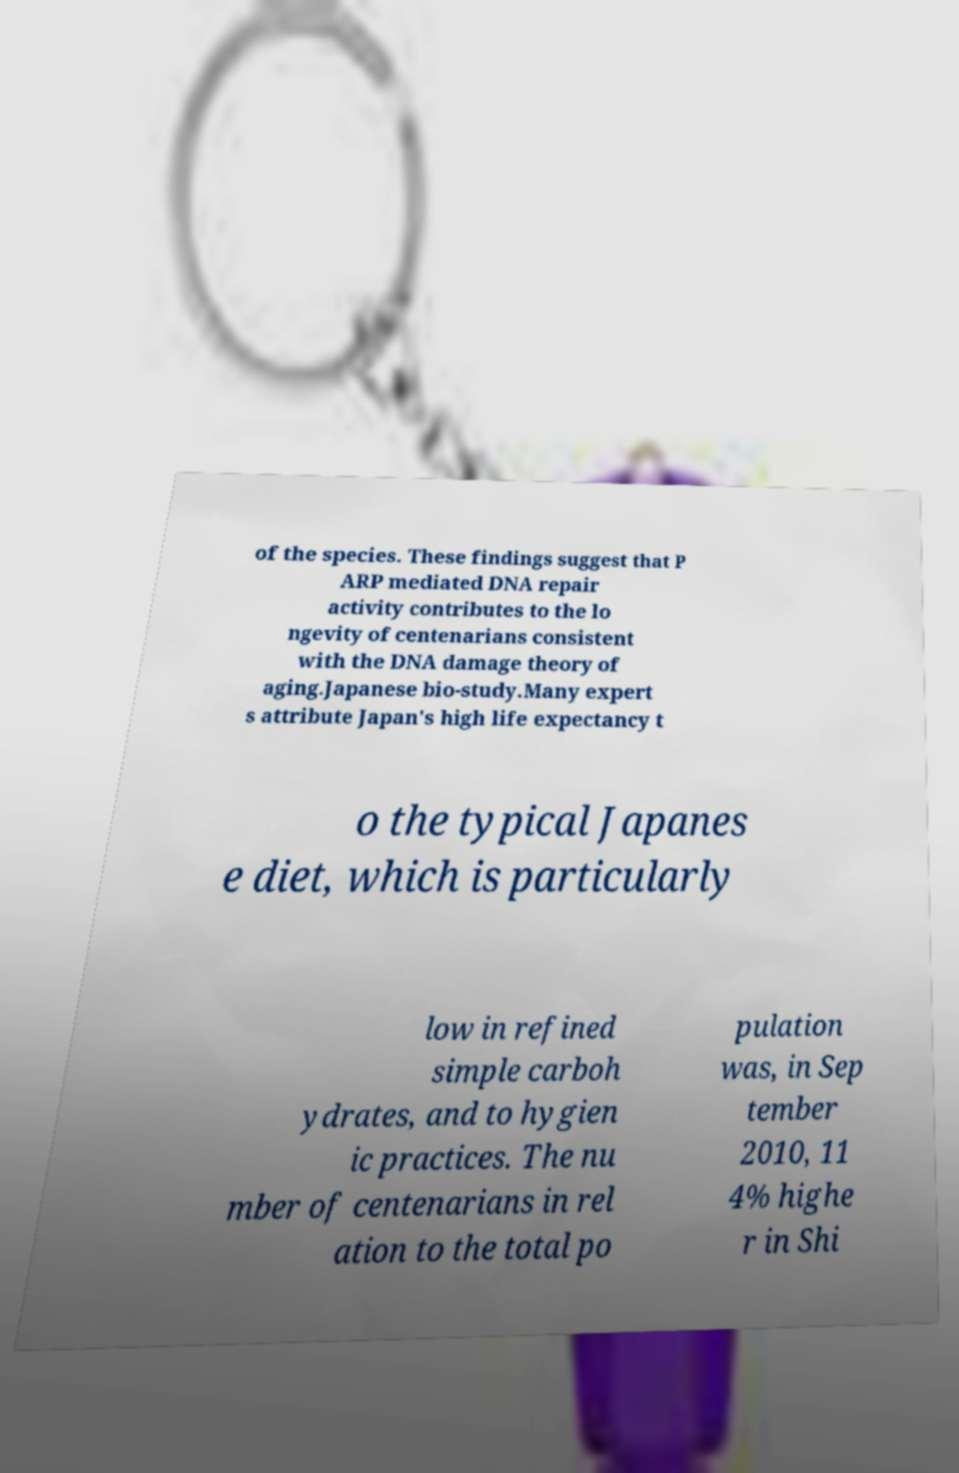Please identify and transcribe the text found in this image. of the species. These findings suggest that P ARP mediated DNA repair activity contributes to the lo ngevity of centenarians consistent with the DNA damage theory of aging.Japanese bio-study.Many expert s attribute Japan's high life expectancy t o the typical Japanes e diet, which is particularly low in refined simple carboh ydrates, and to hygien ic practices. The nu mber of centenarians in rel ation to the total po pulation was, in Sep tember 2010, 11 4% highe r in Shi 